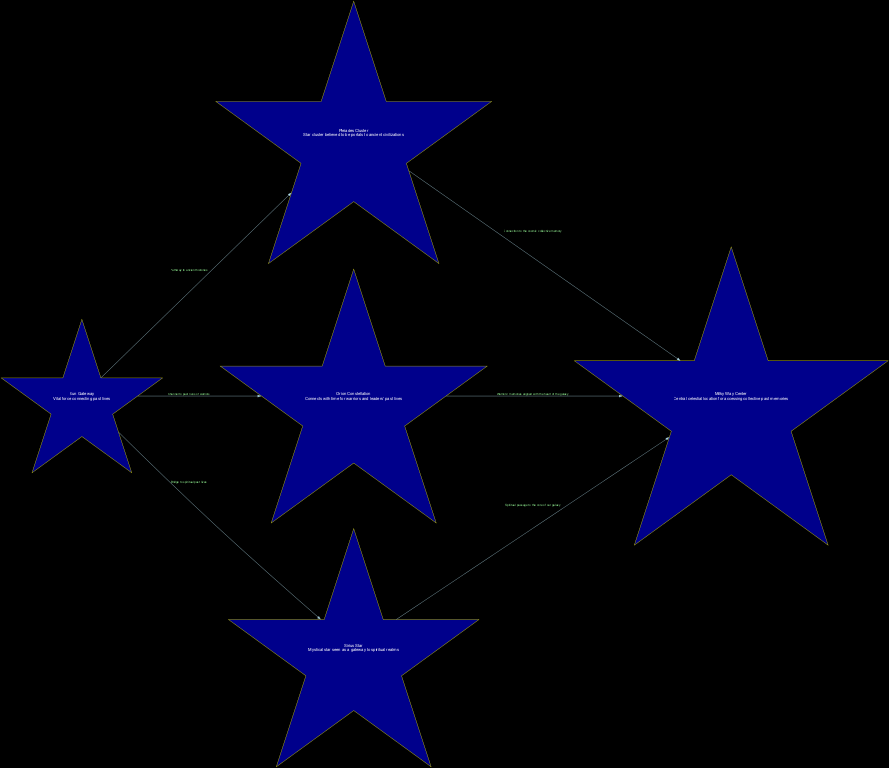What is the total number of nodes in the diagram? Counting the individual elements labeled as nodes reveals that there are five distinct nodes present: Sun Gateway, Pleiades Cluster, Orion Constellation, Sirius Star, and Milky Way Center.
Answer: 5 What does the Sun Gateway connect to? By examining the edges emanating from the Sun Gateway, it connects to three nodes: Pleiades Cluster, Orion Constellation, and Sirius Star.
Answer: Pleiades Cluster, Orion Constellation, Sirius Star Which node is described as connecting to the "cosmic collective memory"? The edge from the Pleiades Cluster indicates it connects to the Milky Way Center, which is described as the "Connection to the cosmic collective memory."
Answer: Milky Way Center What is the relationship between Orion Constellation and Milky Way Center? The edge from Orion Constellation to Milky Way Center describes the connection as "Warriors' memories aligned with the heart of the galaxy," indicating a direct relationship.
Answer: Warriors' memories aligned with the heart of the galaxy Which celestial gateway is believed to lead to spiritual past lives? Examining the description associated with Sirius Star, it states that it serves as a "Mystical star seen as a gateway to spiritual realms," which implies it is the celestial gateway connected to spiritual past lives.
Answer: Sirius Star What is the main function of the Milky Way Center in this diagram? The Milky Way Center is presented as a central celestial location for accessing collective past memories, making it vital for overall connections in the diagram.
Answer: Central celestial location for accessing collective past memories What type of memories does the connection from the Sun Gateway to Orion Constellation refer to? The description of the edge from Sun Gateway to Orion Constellation specifies it as a "Channel to past lives of warriors," which clearly indicates that it refers to warriors' memories.
Answer: Channel to past lives of warriors How many connections does the Pleiades Cluster have? The Pleiades Cluster connects to two nodes: Sun Gateway and Milky Way Center, providing it with a total of two connections.
Answer: 2 Which node indicates a pathway to ancient histories? The pathway to ancient histories is illustrated through the edge connecting the Sun Gateway to the Pleiades Cluster, as described in the diagram.
Answer: Pleiades Cluster 